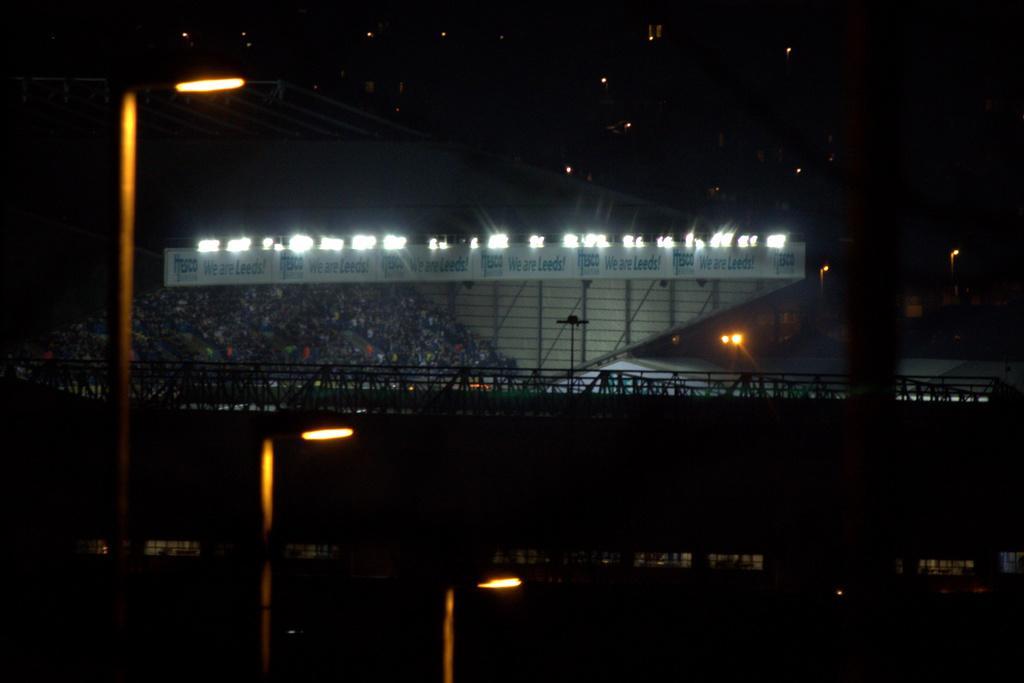Could you give a brief overview of what you see in this image? In this image, we can see poles with lights, hoarding, roads. Background there is a dark view. 